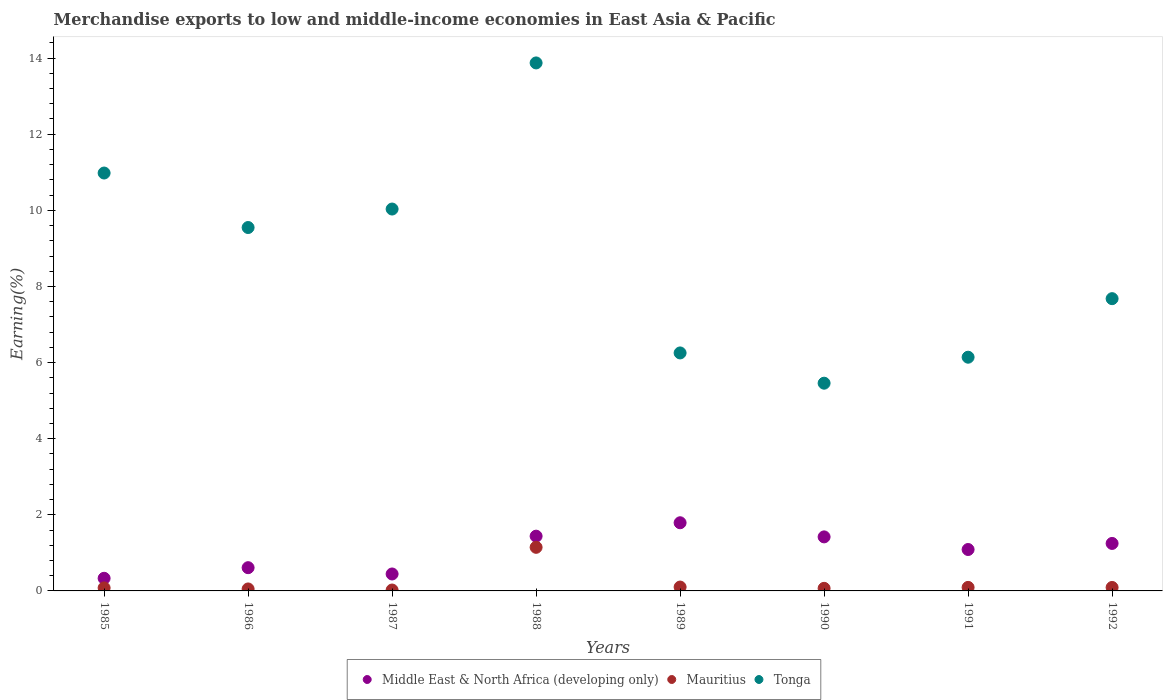How many different coloured dotlines are there?
Provide a short and direct response. 3. What is the percentage of amount earned from merchandise exports in Middle East & North Africa (developing only) in 1991?
Offer a terse response. 1.09. Across all years, what is the maximum percentage of amount earned from merchandise exports in Tonga?
Keep it short and to the point. 13.87. Across all years, what is the minimum percentage of amount earned from merchandise exports in Middle East & North Africa (developing only)?
Your response must be concise. 0.33. In which year was the percentage of amount earned from merchandise exports in Mauritius maximum?
Your answer should be very brief. 1988. What is the total percentage of amount earned from merchandise exports in Tonga in the graph?
Keep it short and to the point. 69.97. What is the difference between the percentage of amount earned from merchandise exports in Tonga in 1989 and that in 1992?
Your response must be concise. -1.43. What is the difference between the percentage of amount earned from merchandise exports in Mauritius in 1992 and the percentage of amount earned from merchandise exports in Middle East & North Africa (developing only) in 1986?
Your answer should be very brief. -0.52. What is the average percentage of amount earned from merchandise exports in Tonga per year?
Offer a terse response. 8.75. In the year 1989, what is the difference between the percentage of amount earned from merchandise exports in Mauritius and percentage of amount earned from merchandise exports in Middle East & North Africa (developing only)?
Offer a very short reply. -1.69. In how many years, is the percentage of amount earned from merchandise exports in Mauritius greater than 11.6 %?
Provide a succinct answer. 0. What is the ratio of the percentage of amount earned from merchandise exports in Tonga in 1986 to that in 1991?
Offer a very short reply. 1.55. Is the percentage of amount earned from merchandise exports in Middle East & North Africa (developing only) in 1986 less than that in 1990?
Provide a succinct answer. Yes. What is the difference between the highest and the second highest percentage of amount earned from merchandise exports in Middle East & North Africa (developing only)?
Your answer should be very brief. 0.35. What is the difference between the highest and the lowest percentage of amount earned from merchandise exports in Tonga?
Ensure brevity in your answer.  8.42. In how many years, is the percentage of amount earned from merchandise exports in Tonga greater than the average percentage of amount earned from merchandise exports in Tonga taken over all years?
Your answer should be compact. 4. Is the percentage of amount earned from merchandise exports in Tonga strictly greater than the percentage of amount earned from merchandise exports in Middle East & North Africa (developing only) over the years?
Offer a very short reply. Yes. Is the percentage of amount earned from merchandise exports in Mauritius strictly less than the percentage of amount earned from merchandise exports in Tonga over the years?
Your answer should be compact. Yes. What is the difference between two consecutive major ticks on the Y-axis?
Provide a succinct answer. 2. Are the values on the major ticks of Y-axis written in scientific E-notation?
Offer a very short reply. No. Does the graph contain any zero values?
Your answer should be very brief. No. Does the graph contain grids?
Provide a short and direct response. No. What is the title of the graph?
Offer a terse response. Merchandise exports to low and middle-income economies in East Asia & Pacific. Does "Sierra Leone" appear as one of the legend labels in the graph?
Provide a short and direct response. No. What is the label or title of the Y-axis?
Ensure brevity in your answer.  Earning(%). What is the Earning(%) in Middle East & North Africa (developing only) in 1985?
Ensure brevity in your answer.  0.33. What is the Earning(%) in Mauritius in 1985?
Make the answer very short. 0.08. What is the Earning(%) of Tonga in 1985?
Keep it short and to the point. 10.98. What is the Earning(%) of Middle East & North Africa (developing only) in 1986?
Your answer should be very brief. 0.61. What is the Earning(%) of Mauritius in 1986?
Provide a succinct answer. 0.05. What is the Earning(%) of Tonga in 1986?
Your response must be concise. 9.55. What is the Earning(%) of Middle East & North Africa (developing only) in 1987?
Make the answer very short. 0.45. What is the Earning(%) in Mauritius in 1987?
Offer a terse response. 0.02. What is the Earning(%) of Tonga in 1987?
Provide a succinct answer. 10.03. What is the Earning(%) of Middle East & North Africa (developing only) in 1988?
Your response must be concise. 1.44. What is the Earning(%) in Mauritius in 1988?
Keep it short and to the point. 1.15. What is the Earning(%) of Tonga in 1988?
Offer a very short reply. 13.87. What is the Earning(%) in Middle East & North Africa (developing only) in 1989?
Your answer should be compact. 1.79. What is the Earning(%) in Mauritius in 1989?
Keep it short and to the point. 0.1. What is the Earning(%) in Tonga in 1989?
Ensure brevity in your answer.  6.25. What is the Earning(%) in Middle East & North Africa (developing only) in 1990?
Provide a succinct answer. 1.42. What is the Earning(%) of Mauritius in 1990?
Provide a succinct answer. 0.07. What is the Earning(%) of Tonga in 1990?
Provide a succinct answer. 5.46. What is the Earning(%) of Middle East & North Africa (developing only) in 1991?
Offer a very short reply. 1.09. What is the Earning(%) in Mauritius in 1991?
Give a very brief answer. 0.09. What is the Earning(%) of Tonga in 1991?
Provide a short and direct response. 6.14. What is the Earning(%) in Middle East & North Africa (developing only) in 1992?
Your response must be concise. 1.25. What is the Earning(%) of Mauritius in 1992?
Ensure brevity in your answer.  0.09. What is the Earning(%) in Tonga in 1992?
Offer a very short reply. 7.68. Across all years, what is the maximum Earning(%) in Middle East & North Africa (developing only)?
Ensure brevity in your answer.  1.79. Across all years, what is the maximum Earning(%) in Mauritius?
Ensure brevity in your answer.  1.15. Across all years, what is the maximum Earning(%) of Tonga?
Your response must be concise. 13.87. Across all years, what is the minimum Earning(%) of Middle East & North Africa (developing only)?
Your answer should be compact. 0.33. Across all years, what is the minimum Earning(%) in Mauritius?
Offer a terse response. 0.02. Across all years, what is the minimum Earning(%) of Tonga?
Give a very brief answer. 5.46. What is the total Earning(%) of Middle East & North Africa (developing only) in the graph?
Your response must be concise. 8.37. What is the total Earning(%) in Mauritius in the graph?
Your response must be concise. 1.65. What is the total Earning(%) in Tonga in the graph?
Provide a short and direct response. 69.97. What is the difference between the Earning(%) in Middle East & North Africa (developing only) in 1985 and that in 1986?
Ensure brevity in your answer.  -0.28. What is the difference between the Earning(%) of Mauritius in 1985 and that in 1986?
Your answer should be very brief. 0.03. What is the difference between the Earning(%) in Tonga in 1985 and that in 1986?
Your answer should be compact. 1.43. What is the difference between the Earning(%) in Middle East & North Africa (developing only) in 1985 and that in 1987?
Offer a terse response. -0.11. What is the difference between the Earning(%) of Mauritius in 1985 and that in 1987?
Your answer should be compact. 0.06. What is the difference between the Earning(%) of Tonga in 1985 and that in 1987?
Keep it short and to the point. 0.95. What is the difference between the Earning(%) in Middle East & North Africa (developing only) in 1985 and that in 1988?
Your answer should be compact. -1.11. What is the difference between the Earning(%) in Mauritius in 1985 and that in 1988?
Make the answer very short. -1.07. What is the difference between the Earning(%) in Tonga in 1985 and that in 1988?
Keep it short and to the point. -2.89. What is the difference between the Earning(%) of Middle East & North Africa (developing only) in 1985 and that in 1989?
Your answer should be very brief. -1.46. What is the difference between the Earning(%) in Mauritius in 1985 and that in 1989?
Offer a terse response. -0.02. What is the difference between the Earning(%) of Tonga in 1985 and that in 1989?
Give a very brief answer. 4.73. What is the difference between the Earning(%) in Middle East & North Africa (developing only) in 1985 and that in 1990?
Ensure brevity in your answer.  -1.09. What is the difference between the Earning(%) in Mauritius in 1985 and that in 1990?
Ensure brevity in your answer.  0.01. What is the difference between the Earning(%) in Tonga in 1985 and that in 1990?
Keep it short and to the point. 5.52. What is the difference between the Earning(%) in Middle East & North Africa (developing only) in 1985 and that in 1991?
Give a very brief answer. -0.76. What is the difference between the Earning(%) of Mauritius in 1985 and that in 1991?
Offer a very short reply. -0.01. What is the difference between the Earning(%) in Tonga in 1985 and that in 1991?
Ensure brevity in your answer.  4.84. What is the difference between the Earning(%) of Middle East & North Africa (developing only) in 1985 and that in 1992?
Make the answer very short. -0.92. What is the difference between the Earning(%) of Mauritius in 1985 and that in 1992?
Give a very brief answer. -0.01. What is the difference between the Earning(%) of Tonga in 1985 and that in 1992?
Ensure brevity in your answer.  3.3. What is the difference between the Earning(%) in Middle East & North Africa (developing only) in 1986 and that in 1987?
Give a very brief answer. 0.17. What is the difference between the Earning(%) of Mauritius in 1986 and that in 1987?
Give a very brief answer. 0.03. What is the difference between the Earning(%) in Tonga in 1986 and that in 1987?
Your response must be concise. -0.49. What is the difference between the Earning(%) of Middle East & North Africa (developing only) in 1986 and that in 1988?
Provide a succinct answer. -0.83. What is the difference between the Earning(%) in Mauritius in 1986 and that in 1988?
Provide a short and direct response. -1.09. What is the difference between the Earning(%) in Tonga in 1986 and that in 1988?
Provide a short and direct response. -4.32. What is the difference between the Earning(%) in Middle East & North Africa (developing only) in 1986 and that in 1989?
Provide a succinct answer. -1.18. What is the difference between the Earning(%) of Mauritius in 1986 and that in 1989?
Your response must be concise. -0.05. What is the difference between the Earning(%) of Tonga in 1986 and that in 1989?
Make the answer very short. 3.3. What is the difference between the Earning(%) of Middle East & North Africa (developing only) in 1986 and that in 1990?
Your response must be concise. -0.81. What is the difference between the Earning(%) of Mauritius in 1986 and that in 1990?
Provide a short and direct response. -0.02. What is the difference between the Earning(%) of Tonga in 1986 and that in 1990?
Keep it short and to the point. 4.09. What is the difference between the Earning(%) of Middle East & North Africa (developing only) in 1986 and that in 1991?
Your answer should be compact. -0.48. What is the difference between the Earning(%) in Mauritius in 1986 and that in 1991?
Ensure brevity in your answer.  -0.04. What is the difference between the Earning(%) of Tonga in 1986 and that in 1991?
Keep it short and to the point. 3.41. What is the difference between the Earning(%) in Middle East & North Africa (developing only) in 1986 and that in 1992?
Your answer should be very brief. -0.64. What is the difference between the Earning(%) of Mauritius in 1986 and that in 1992?
Your response must be concise. -0.04. What is the difference between the Earning(%) of Tonga in 1986 and that in 1992?
Provide a succinct answer. 1.87. What is the difference between the Earning(%) in Middle East & North Africa (developing only) in 1987 and that in 1988?
Your response must be concise. -0.99. What is the difference between the Earning(%) in Mauritius in 1987 and that in 1988?
Provide a short and direct response. -1.12. What is the difference between the Earning(%) in Tonga in 1987 and that in 1988?
Keep it short and to the point. -3.84. What is the difference between the Earning(%) in Middle East & North Africa (developing only) in 1987 and that in 1989?
Your answer should be very brief. -1.35. What is the difference between the Earning(%) in Mauritius in 1987 and that in 1989?
Provide a short and direct response. -0.08. What is the difference between the Earning(%) of Tonga in 1987 and that in 1989?
Offer a very short reply. 3.78. What is the difference between the Earning(%) in Middle East & North Africa (developing only) in 1987 and that in 1990?
Your answer should be compact. -0.97. What is the difference between the Earning(%) in Mauritius in 1987 and that in 1990?
Provide a short and direct response. -0.04. What is the difference between the Earning(%) in Tonga in 1987 and that in 1990?
Offer a very short reply. 4.58. What is the difference between the Earning(%) of Middle East & North Africa (developing only) in 1987 and that in 1991?
Offer a terse response. -0.64. What is the difference between the Earning(%) of Mauritius in 1987 and that in 1991?
Keep it short and to the point. -0.07. What is the difference between the Earning(%) in Tonga in 1987 and that in 1991?
Provide a succinct answer. 3.89. What is the difference between the Earning(%) in Middle East & North Africa (developing only) in 1987 and that in 1992?
Provide a short and direct response. -0.8. What is the difference between the Earning(%) in Mauritius in 1987 and that in 1992?
Provide a succinct answer. -0.07. What is the difference between the Earning(%) of Tonga in 1987 and that in 1992?
Provide a short and direct response. 2.35. What is the difference between the Earning(%) of Middle East & North Africa (developing only) in 1988 and that in 1989?
Make the answer very short. -0.35. What is the difference between the Earning(%) in Mauritius in 1988 and that in 1989?
Provide a short and direct response. 1.04. What is the difference between the Earning(%) in Tonga in 1988 and that in 1989?
Your response must be concise. 7.62. What is the difference between the Earning(%) of Middle East & North Africa (developing only) in 1988 and that in 1990?
Your answer should be very brief. 0.02. What is the difference between the Earning(%) in Mauritius in 1988 and that in 1990?
Keep it short and to the point. 1.08. What is the difference between the Earning(%) in Tonga in 1988 and that in 1990?
Your answer should be compact. 8.42. What is the difference between the Earning(%) of Middle East & North Africa (developing only) in 1988 and that in 1991?
Give a very brief answer. 0.35. What is the difference between the Earning(%) in Mauritius in 1988 and that in 1991?
Keep it short and to the point. 1.05. What is the difference between the Earning(%) in Tonga in 1988 and that in 1991?
Offer a terse response. 7.73. What is the difference between the Earning(%) of Middle East & North Africa (developing only) in 1988 and that in 1992?
Ensure brevity in your answer.  0.19. What is the difference between the Earning(%) of Mauritius in 1988 and that in 1992?
Provide a succinct answer. 1.05. What is the difference between the Earning(%) of Tonga in 1988 and that in 1992?
Ensure brevity in your answer.  6.19. What is the difference between the Earning(%) in Middle East & North Africa (developing only) in 1989 and that in 1990?
Provide a short and direct response. 0.37. What is the difference between the Earning(%) of Mauritius in 1989 and that in 1990?
Keep it short and to the point. 0.03. What is the difference between the Earning(%) of Tonga in 1989 and that in 1990?
Offer a terse response. 0.8. What is the difference between the Earning(%) of Middle East & North Africa (developing only) in 1989 and that in 1991?
Provide a succinct answer. 0.7. What is the difference between the Earning(%) in Mauritius in 1989 and that in 1991?
Provide a succinct answer. 0.01. What is the difference between the Earning(%) in Tonga in 1989 and that in 1991?
Offer a very short reply. 0.11. What is the difference between the Earning(%) in Middle East & North Africa (developing only) in 1989 and that in 1992?
Keep it short and to the point. 0.54. What is the difference between the Earning(%) of Mauritius in 1989 and that in 1992?
Offer a terse response. 0.01. What is the difference between the Earning(%) of Tonga in 1989 and that in 1992?
Offer a very short reply. -1.43. What is the difference between the Earning(%) of Middle East & North Africa (developing only) in 1990 and that in 1991?
Offer a terse response. 0.33. What is the difference between the Earning(%) of Mauritius in 1990 and that in 1991?
Your answer should be compact. -0.02. What is the difference between the Earning(%) of Tonga in 1990 and that in 1991?
Offer a very short reply. -0.68. What is the difference between the Earning(%) in Middle East & North Africa (developing only) in 1990 and that in 1992?
Give a very brief answer. 0.17. What is the difference between the Earning(%) in Mauritius in 1990 and that in 1992?
Keep it short and to the point. -0.02. What is the difference between the Earning(%) in Tonga in 1990 and that in 1992?
Make the answer very short. -2.22. What is the difference between the Earning(%) of Middle East & North Africa (developing only) in 1991 and that in 1992?
Give a very brief answer. -0.16. What is the difference between the Earning(%) of Mauritius in 1991 and that in 1992?
Ensure brevity in your answer.  0. What is the difference between the Earning(%) in Tonga in 1991 and that in 1992?
Provide a succinct answer. -1.54. What is the difference between the Earning(%) of Middle East & North Africa (developing only) in 1985 and the Earning(%) of Mauritius in 1986?
Give a very brief answer. 0.28. What is the difference between the Earning(%) of Middle East & North Africa (developing only) in 1985 and the Earning(%) of Tonga in 1986?
Your answer should be very brief. -9.22. What is the difference between the Earning(%) of Mauritius in 1985 and the Earning(%) of Tonga in 1986?
Offer a terse response. -9.47. What is the difference between the Earning(%) in Middle East & North Africa (developing only) in 1985 and the Earning(%) in Mauritius in 1987?
Provide a succinct answer. 0.31. What is the difference between the Earning(%) of Middle East & North Africa (developing only) in 1985 and the Earning(%) of Tonga in 1987?
Keep it short and to the point. -9.7. What is the difference between the Earning(%) of Mauritius in 1985 and the Earning(%) of Tonga in 1987?
Provide a short and direct response. -9.95. What is the difference between the Earning(%) of Middle East & North Africa (developing only) in 1985 and the Earning(%) of Mauritius in 1988?
Give a very brief answer. -0.81. What is the difference between the Earning(%) in Middle East & North Africa (developing only) in 1985 and the Earning(%) in Tonga in 1988?
Ensure brevity in your answer.  -13.54. What is the difference between the Earning(%) in Mauritius in 1985 and the Earning(%) in Tonga in 1988?
Your answer should be compact. -13.79. What is the difference between the Earning(%) of Middle East & North Africa (developing only) in 1985 and the Earning(%) of Mauritius in 1989?
Ensure brevity in your answer.  0.23. What is the difference between the Earning(%) of Middle East & North Africa (developing only) in 1985 and the Earning(%) of Tonga in 1989?
Provide a short and direct response. -5.92. What is the difference between the Earning(%) of Mauritius in 1985 and the Earning(%) of Tonga in 1989?
Provide a succinct answer. -6.17. What is the difference between the Earning(%) in Middle East & North Africa (developing only) in 1985 and the Earning(%) in Mauritius in 1990?
Make the answer very short. 0.26. What is the difference between the Earning(%) of Middle East & North Africa (developing only) in 1985 and the Earning(%) of Tonga in 1990?
Give a very brief answer. -5.13. What is the difference between the Earning(%) in Mauritius in 1985 and the Earning(%) in Tonga in 1990?
Your answer should be very brief. -5.38. What is the difference between the Earning(%) of Middle East & North Africa (developing only) in 1985 and the Earning(%) of Mauritius in 1991?
Ensure brevity in your answer.  0.24. What is the difference between the Earning(%) in Middle East & North Africa (developing only) in 1985 and the Earning(%) in Tonga in 1991?
Make the answer very short. -5.81. What is the difference between the Earning(%) in Mauritius in 1985 and the Earning(%) in Tonga in 1991?
Your answer should be very brief. -6.06. What is the difference between the Earning(%) in Middle East & North Africa (developing only) in 1985 and the Earning(%) in Mauritius in 1992?
Your response must be concise. 0.24. What is the difference between the Earning(%) in Middle East & North Africa (developing only) in 1985 and the Earning(%) in Tonga in 1992?
Offer a very short reply. -7.35. What is the difference between the Earning(%) of Mauritius in 1985 and the Earning(%) of Tonga in 1992?
Your response must be concise. -7.6. What is the difference between the Earning(%) in Middle East & North Africa (developing only) in 1986 and the Earning(%) in Mauritius in 1987?
Provide a short and direct response. 0.59. What is the difference between the Earning(%) in Middle East & North Africa (developing only) in 1986 and the Earning(%) in Tonga in 1987?
Provide a short and direct response. -9.42. What is the difference between the Earning(%) of Mauritius in 1986 and the Earning(%) of Tonga in 1987?
Your response must be concise. -9.98. What is the difference between the Earning(%) of Middle East & North Africa (developing only) in 1986 and the Earning(%) of Mauritius in 1988?
Offer a terse response. -0.54. What is the difference between the Earning(%) of Middle East & North Africa (developing only) in 1986 and the Earning(%) of Tonga in 1988?
Ensure brevity in your answer.  -13.26. What is the difference between the Earning(%) in Mauritius in 1986 and the Earning(%) in Tonga in 1988?
Offer a very short reply. -13.82. What is the difference between the Earning(%) in Middle East & North Africa (developing only) in 1986 and the Earning(%) in Mauritius in 1989?
Offer a very short reply. 0.51. What is the difference between the Earning(%) in Middle East & North Africa (developing only) in 1986 and the Earning(%) in Tonga in 1989?
Offer a terse response. -5.64. What is the difference between the Earning(%) of Mauritius in 1986 and the Earning(%) of Tonga in 1989?
Offer a very short reply. -6.2. What is the difference between the Earning(%) of Middle East & North Africa (developing only) in 1986 and the Earning(%) of Mauritius in 1990?
Your response must be concise. 0.54. What is the difference between the Earning(%) of Middle East & North Africa (developing only) in 1986 and the Earning(%) of Tonga in 1990?
Your answer should be compact. -4.85. What is the difference between the Earning(%) of Mauritius in 1986 and the Earning(%) of Tonga in 1990?
Keep it short and to the point. -5.41. What is the difference between the Earning(%) of Middle East & North Africa (developing only) in 1986 and the Earning(%) of Mauritius in 1991?
Ensure brevity in your answer.  0.52. What is the difference between the Earning(%) of Middle East & North Africa (developing only) in 1986 and the Earning(%) of Tonga in 1991?
Your answer should be very brief. -5.53. What is the difference between the Earning(%) of Mauritius in 1986 and the Earning(%) of Tonga in 1991?
Offer a terse response. -6.09. What is the difference between the Earning(%) of Middle East & North Africa (developing only) in 1986 and the Earning(%) of Mauritius in 1992?
Your response must be concise. 0.52. What is the difference between the Earning(%) of Middle East & North Africa (developing only) in 1986 and the Earning(%) of Tonga in 1992?
Your answer should be compact. -7.07. What is the difference between the Earning(%) in Mauritius in 1986 and the Earning(%) in Tonga in 1992?
Keep it short and to the point. -7.63. What is the difference between the Earning(%) in Middle East & North Africa (developing only) in 1987 and the Earning(%) in Mauritius in 1988?
Offer a terse response. -0.7. What is the difference between the Earning(%) of Middle East & North Africa (developing only) in 1987 and the Earning(%) of Tonga in 1988?
Provide a short and direct response. -13.43. What is the difference between the Earning(%) of Mauritius in 1987 and the Earning(%) of Tonga in 1988?
Your answer should be compact. -13.85. What is the difference between the Earning(%) in Middle East & North Africa (developing only) in 1987 and the Earning(%) in Mauritius in 1989?
Offer a very short reply. 0.34. What is the difference between the Earning(%) in Middle East & North Africa (developing only) in 1987 and the Earning(%) in Tonga in 1989?
Provide a short and direct response. -5.81. What is the difference between the Earning(%) in Mauritius in 1987 and the Earning(%) in Tonga in 1989?
Your answer should be very brief. -6.23. What is the difference between the Earning(%) of Middle East & North Africa (developing only) in 1987 and the Earning(%) of Mauritius in 1990?
Provide a short and direct response. 0.38. What is the difference between the Earning(%) in Middle East & North Africa (developing only) in 1987 and the Earning(%) in Tonga in 1990?
Ensure brevity in your answer.  -5.01. What is the difference between the Earning(%) of Mauritius in 1987 and the Earning(%) of Tonga in 1990?
Offer a very short reply. -5.43. What is the difference between the Earning(%) in Middle East & North Africa (developing only) in 1987 and the Earning(%) in Mauritius in 1991?
Ensure brevity in your answer.  0.35. What is the difference between the Earning(%) of Middle East & North Africa (developing only) in 1987 and the Earning(%) of Tonga in 1991?
Offer a very short reply. -5.7. What is the difference between the Earning(%) of Mauritius in 1987 and the Earning(%) of Tonga in 1991?
Your answer should be compact. -6.12. What is the difference between the Earning(%) in Middle East & North Africa (developing only) in 1987 and the Earning(%) in Mauritius in 1992?
Give a very brief answer. 0.35. What is the difference between the Earning(%) of Middle East & North Africa (developing only) in 1987 and the Earning(%) of Tonga in 1992?
Provide a succinct answer. -7.23. What is the difference between the Earning(%) of Mauritius in 1987 and the Earning(%) of Tonga in 1992?
Keep it short and to the point. -7.66. What is the difference between the Earning(%) of Middle East & North Africa (developing only) in 1988 and the Earning(%) of Mauritius in 1989?
Ensure brevity in your answer.  1.34. What is the difference between the Earning(%) of Middle East & North Africa (developing only) in 1988 and the Earning(%) of Tonga in 1989?
Provide a short and direct response. -4.81. What is the difference between the Earning(%) of Mauritius in 1988 and the Earning(%) of Tonga in 1989?
Offer a very short reply. -5.11. What is the difference between the Earning(%) of Middle East & North Africa (developing only) in 1988 and the Earning(%) of Mauritius in 1990?
Give a very brief answer. 1.37. What is the difference between the Earning(%) in Middle East & North Africa (developing only) in 1988 and the Earning(%) in Tonga in 1990?
Make the answer very short. -4.02. What is the difference between the Earning(%) of Mauritius in 1988 and the Earning(%) of Tonga in 1990?
Provide a short and direct response. -4.31. What is the difference between the Earning(%) in Middle East & North Africa (developing only) in 1988 and the Earning(%) in Mauritius in 1991?
Your response must be concise. 1.35. What is the difference between the Earning(%) in Middle East & North Africa (developing only) in 1988 and the Earning(%) in Tonga in 1991?
Give a very brief answer. -4.7. What is the difference between the Earning(%) in Mauritius in 1988 and the Earning(%) in Tonga in 1991?
Your answer should be very brief. -5. What is the difference between the Earning(%) of Middle East & North Africa (developing only) in 1988 and the Earning(%) of Mauritius in 1992?
Make the answer very short. 1.35. What is the difference between the Earning(%) of Middle East & North Africa (developing only) in 1988 and the Earning(%) of Tonga in 1992?
Give a very brief answer. -6.24. What is the difference between the Earning(%) of Mauritius in 1988 and the Earning(%) of Tonga in 1992?
Offer a very short reply. -6.53. What is the difference between the Earning(%) of Middle East & North Africa (developing only) in 1989 and the Earning(%) of Mauritius in 1990?
Keep it short and to the point. 1.72. What is the difference between the Earning(%) in Middle East & North Africa (developing only) in 1989 and the Earning(%) in Tonga in 1990?
Your response must be concise. -3.67. What is the difference between the Earning(%) in Mauritius in 1989 and the Earning(%) in Tonga in 1990?
Provide a short and direct response. -5.36. What is the difference between the Earning(%) in Middle East & North Africa (developing only) in 1989 and the Earning(%) in Mauritius in 1991?
Provide a succinct answer. 1.7. What is the difference between the Earning(%) of Middle East & North Africa (developing only) in 1989 and the Earning(%) of Tonga in 1991?
Offer a very short reply. -4.35. What is the difference between the Earning(%) of Mauritius in 1989 and the Earning(%) of Tonga in 1991?
Provide a short and direct response. -6.04. What is the difference between the Earning(%) of Middle East & North Africa (developing only) in 1989 and the Earning(%) of Mauritius in 1992?
Your answer should be compact. 1.7. What is the difference between the Earning(%) of Middle East & North Africa (developing only) in 1989 and the Earning(%) of Tonga in 1992?
Make the answer very short. -5.89. What is the difference between the Earning(%) of Mauritius in 1989 and the Earning(%) of Tonga in 1992?
Provide a succinct answer. -7.58. What is the difference between the Earning(%) in Middle East & North Africa (developing only) in 1990 and the Earning(%) in Mauritius in 1991?
Make the answer very short. 1.33. What is the difference between the Earning(%) of Middle East & North Africa (developing only) in 1990 and the Earning(%) of Tonga in 1991?
Your answer should be very brief. -4.72. What is the difference between the Earning(%) in Mauritius in 1990 and the Earning(%) in Tonga in 1991?
Your response must be concise. -6.07. What is the difference between the Earning(%) of Middle East & North Africa (developing only) in 1990 and the Earning(%) of Mauritius in 1992?
Offer a very short reply. 1.33. What is the difference between the Earning(%) of Middle East & North Africa (developing only) in 1990 and the Earning(%) of Tonga in 1992?
Your answer should be very brief. -6.26. What is the difference between the Earning(%) of Mauritius in 1990 and the Earning(%) of Tonga in 1992?
Give a very brief answer. -7.61. What is the difference between the Earning(%) in Middle East & North Africa (developing only) in 1991 and the Earning(%) in Mauritius in 1992?
Keep it short and to the point. 1. What is the difference between the Earning(%) of Middle East & North Africa (developing only) in 1991 and the Earning(%) of Tonga in 1992?
Ensure brevity in your answer.  -6.59. What is the difference between the Earning(%) in Mauritius in 1991 and the Earning(%) in Tonga in 1992?
Ensure brevity in your answer.  -7.59. What is the average Earning(%) in Middle East & North Africa (developing only) per year?
Provide a succinct answer. 1.05. What is the average Earning(%) of Mauritius per year?
Ensure brevity in your answer.  0.21. What is the average Earning(%) in Tonga per year?
Provide a short and direct response. 8.75. In the year 1985, what is the difference between the Earning(%) in Middle East & North Africa (developing only) and Earning(%) in Mauritius?
Offer a terse response. 0.25. In the year 1985, what is the difference between the Earning(%) of Middle East & North Africa (developing only) and Earning(%) of Tonga?
Provide a short and direct response. -10.65. In the year 1985, what is the difference between the Earning(%) of Mauritius and Earning(%) of Tonga?
Make the answer very short. -10.9. In the year 1986, what is the difference between the Earning(%) in Middle East & North Africa (developing only) and Earning(%) in Mauritius?
Offer a terse response. 0.56. In the year 1986, what is the difference between the Earning(%) of Middle East & North Africa (developing only) and Earning(%) of Tonga?
Ensure brevity in your answer.  -8.94. In the year 1986, what is the difference between the Earning(%) of Mauritius and Earning(%) of Tonga?
Offer a terse response. -9.5. In the year 1987, what is the difference between the Earning(%) in Middle East & North Africa (developing only) and Earning(%) in Mauritius?
Provide a short and direct response. 0.42. In the year 1987, what is the difference between the Earning(%) of Middle East & North Africa (developing only) and Earning(%) of Tonga?
Your answer should be compact. -9.59. In the year 1987, what is the difference between the Earning(%) of Mauritius and Earning(%) of Tonga?
Offer a terse response. -10.01. In the year 1988, what is the difference between the Earning(%) in Middle East & North Africa (developing only) and Earning(%) in Mauritius?
Give a very brief answer. 0.29. In the year 1988, what is the difference between the Earning(%) of Middle East & North Africa (developing only) and Earning(%) of Tonga?
Provide a succinct answer. -12.43. In the year 1988, what is the difference between the Earning(%) in Mauritius and Earning(%) in Tonga?
Offer a terse response. -12.73. In the year 1989, what is the difference between the Earning(%) of Middle East & North Africa (developing only) and Earning(%) of Mauritius?
Make the answer very short. 1.69. In the year 1989, what is the difference between the Earning(%) of Middle East & North Africa (developing only) and Earning(%) of Tonga?
Provide a succinct answer. -4.46. In the year 1989, what is the difference between the Earning(%) in Mauritius and Earning(%) in Tonga?
Provide a succinct answer. -6.15. In the year 1990, what is the difference between the Earning(%) of Middle East & North Africa (developing only) and Earning(%) of Mauritius?
Make the answer very short. 1.35. In the year 1990, what is the difference between the Earning(%) in Middle East & North Africa (developing only) and Earning(%) in Tonga?
Keep it short and to the point. -4.04. In the year 1990, what is the difference between the Earning(%) in Mauritius and Earning(%) in Tonga?
Offer a very short reply. -5.39. In the year 1991, what is the difference between the Earning(%) of Middle East & North Africa (developing only) and Earning(%) of Tonga?
Offer a terse response. -5.05. In the year 1991, what is the difference between the Earning(%) of Mauritius and Earning(%) of Tonga?
Give a very brief answer. -6.05. In the year 1992, what is the difference between the Earning(%) in Middle East & North Africa (developing only) and Earning(%) in Mauritius?
Your response must be concise. 1.16. In the year 1992, what is the difference between the Earning(%) in Middle East & North Africa (developing only) and Earning(%) in Tonga?
Offer a terse response. -6.43. In the year 1992, what is the difference between the Earning(%) in Mauritius and Earning(%) in Tonga?
Your answer should be compact. -7.59. What is the ratio of the Earning(%) of Middle East & North Africa (developing only) in 1985 to that in 1986?
Your response must be concise. 0.54. What is the ratio of the Earning(%) in Mauritius in 1985 to that in 1986?
Make the answer very short. 1.53. What is the ratio of the Earning(%) in Tonga in 1985 to that in 1986?
Offer a very short reply. 1.15. What is the ratio of the Earning(%) of Middle East & North Africa (developing only) in 1985 to that in 1987?
Your response must be concise. 0.75. What is the ratio of the Earning(%) in Mauritius in 1985 to that in 1987?
Your answer should be very brief. 3.35. What is the ratio of the Earning(%) of Tonga in 1985 to that in 1987?
Your answer should be compact. 1.09. What is the ratio of the Earning(%) of Middle East & North Africa (developing only) in 1985 to that in 1988?
Your response must be concise. 0.23. What is the ratio of the Earning(%) in Mauritius in 1985 to that in 1988?
Offer a very short reply. 0.07. What is the ratio of the Earning(%) of Tonga in 1985 to that in 1988?
Keep it short and to the point. 0.79. What is the ratio of the Earning(%) of Middle East & North Africa (developing only) in 1985 to that in 1989?
Your response must be concise. 0.19. What is the ratio of the Earning(%) in Mauritius in 1985 to that in 1989?
Offer a terse response. 0.78. What is the ratio of the Earning(%) in Tonga in 1985 to that in 1989?
Make the answer very short. 1.76. What is the ratio of the Earning(%) of Middle East & North Africa (developing only) in 1985 to that in 1990?
Offer a terse response. 0.23. What is the ratio of the Earning(%) of Mauritius in 1985 to that in 1990?
Provide a short and direct response. 1.17. What is the ratio of the Earning(%) in Tonga in 1985 to that in 1990?
Make the answer very short. 2.01. What is the ratio of the Earning(%) of Middle East & North Africa (developing only) in 1985 to that in 1991?
Ensure brevity in your answer.  0.3. What is the ratio of the Earning(%) in Mauritius in 1985 to that in 1991?
Give a very brief answer. 0.86. What is the ratio of the Earning(%) in Tonga in 1985 to that in 1991?
Your answer should be very brief. 1.79. What is the ratio of the Earning(%) of Middle East & North Africa (developing only) in 1985 to that in 1992?
Provide a short and direct response. 0.27. What is the ratio of the Earning(%) in Mauritius in 1985 to that in 1992?
Provide a short and direct response. 0.87. What is the ratio of the Earning(%) in Tonga in 1985 to that in 1992?
Provide a short and direct response. 1.43. What is the ratio of the Earning(%) of Middle East & North Africa (developing only) in 1986 to that in 1987?
Keep it short and to the point. 1.37. What is the ratio of the Earning(%) of Mauritius in 1986 to that in 1987?
Your answer should be very brief. 2.19. What is the ratio of the Earning(%) of Tonga in 1986 to that in 1987?
Make the answer very short. 0.95. What is the ratio of the Earning(%) in Middle East & North Africa (developing only) in 1986 to that in 1988?
Provide a short and direct response. 0.42. What is the ratio of the Earning(%) in Mauritius in 1986 to that in 1988?
Give a very brief answer. 0.05. What is the ratio of the Earning(%) of Tonga in 1986 to that in 1988?
Your answer should be compact. 0.69. What is the ratio of the Earning(%) of Middle East & North Africa (developing only) in 1986 to that in 1989?
Offer a very short reply. 0.34. What is the ratio of the Earning(%) of Mauritius in 1986 to that in 1989?
Your response must be concise. 0.51. What is the ratio of the Earning(%) in Tonga in 1986 to that in 1989?
Provide a short and direct response. 1.53. What is the ratio of the Earning(%) in Middle East & North Africa (developing only) in 1986 to that in 1990?
Your response must be concise. 0.43. What is the ratio of the Earning(%) of Mauritius in 1986 to that in 1990?
Your answer should be very brief. 0.76. What is the ratio of the Earning(%) in Tonga in 1986 to that in 1990?
Give a very brief answer. 1.75. What is the ratio of the Earning(%) in Middle East & North Africa (developing only) in 1986 to that in 1991?
Ensure brevity in your answer.  0.56. What is the ratio of the Earning(%) in Mauritius in 1986 to that in 1991?
Make the answer very short. 0.56. What is the ratio of the Earning(%) of Tonga in 1986 to that in 1991?
Your answer should be compact. 1.55. What is the ratio of the Earning(%) in Middle East & North Africa (developing only) in 1986 to that in 1992?
Offer a terse response. 0.49. What is the ratio of the Earning(%) of Mauritius in 1986 to that in 1992?
Provide a short and direct response. 0.57. What is the ratio of the Earning(%) of Tonga in 1986 to that in 1992?
Your answer should be very brief. 1.24. What is the ratio of the Earning(%) of Middle East & North Africa (developing only) in 1987 to that in 1988?
Your answer should be compact. 0.31. What is the ratio of the Earning(%) of Mauritius in 1987 to that in 1988?
Offer a very short reply. 0.02. What is the ratio of the Earning(%) in Tonga in 1987 to that in 1988?
Offer a terse response. 0.72. What is the ratio of the Earning(%) of Middle East & North Africa (developing only) in 1987 to that in 1989?
Your answer should be compact. 0.25. What is the ratio of the Earning(%) in Mauritius in 1987 to that in 1989?
Your answer should be very brief. 0.23. What is the ratio of the Earning(%) in Tonga in 1987 to that in 1989?
Provide a succinct answer. 1.6. What is the ratio of the Earning(%) of Middle East & North Africa (developing only) in 1987 to that in 1990?
Offer a terse response. 0.31. What is the ratio of the Earning(%) of Mauritius in 1987 to that in 1990?
Provide a short and direct response. 0.35. What is the ratio of the Earning(%) of Tonga in 1987 to that in 1990?
Your answer should be compact. 1.84. What is the ratio of the Earning(%) in Middle East & North Africa (developing only) in 1987 to that in 1991?
Provide a short and direct response. 0.41. What is the ratio of the Earning(%) of Mauritius in 1987 to that in 1991?
Your response must be concise. 0.26. What is the ratio of the Earning(%) in Tonga in 1987 to that in 1991?
Keep it short and to the point. 1.63. What is the ratio of the Earning(%) in Middle East & North Africa (developing only) in 1987 to that in 1992?
Give a very brief answer. 0.36. What is the ratio of the Earning(%) in Mauritius in 1987 to that in 1992?
Your answer should be compact. 0.26. What is the ratio of the Earning(%) of Tonga in 1987 to that in 1992?
Your answer should be compact. 1.31. What is the ratio of the Earning(%) in Middle East & North Africa (developing only) in 1988 to that in 1989?
Ensure brevity in your answer.  0.8. What is the ratio of the Earning(%) of Mauritius in 1988 to that in 1989?
Provide a succinct answer. 11.26. What is the ratio of the Earning(%) in Tonga in 1988 to that in 1989?
Offer a terse response. 2.22. What is the ratio of the Earning(%) in Middle East & North Africa (developing only) in 1988 to that in 1990?
Your answer should be compact. 1.01. What is the ratio of the Earning(%) of Mauritius in 1988 to that in 1990?
Give a very brief answer. 16.89. What is the ratio of the Earning(%) in Tonga in 1988 to that in 1990?
Provide a short and direct response. 2.54. What is the ratio of the Earning(%) of Middle East & North Africa (developing only) in 1988 to that in 1991?
Give a very brief answer. 1.32. What is the ratio of the Earning(%) of Mauritius in 1988 to that in 1991?
Provide a short and direct response. 12.36. What is the ratio of the Earning(%) in Tonga in 1988 to that in 1991?
Keep it short and to the point. 2.26. What is the ratio of the Earning(%) in Middle East & North Africa (developing only) in 1988 to that in 1992?
Ensure brevity in your answer.  1.15. What is the ratio of the Earning(%) of Mauritius in 1988 to that in 1992?
Ensure brevity in your answer.  12.6. What is the ratio of the Earning(%) in Tonga in 1988 to that in 1992?
Provide a succinct answer. 1.81. What is the ratio of the Earning(%) of Middle East & North Africa (developing only) in 1989 to that in 1990?
Your response must be concise. 1.26. What is the ratio of the Earning(%) of Mauritius in 1989 to that in 1990?
Ensure brevity in your answer.  1.5. What is the ratio of the Earning(%) in Tonga in 1989 to that in 1990?
Offer a very short reply. 1.15. What is the ratio of the Earning(%) in Middle East & North Africa (developing only) in 1989 to that in 1991?
Your response must be concise. 1.65. What is the ratio of the Earning(%) in Mauritius in 1989 to that in 1991?
Provide a succinct answer. 1.1. What is the ratio of the Earning(%) in Tonga in 1989 to that in 1991?
Your response must be concise. 1.02. What is the ratio of the Earning(%) in Middle East & North Africa (developing only) in 1989 to that in 1992?
Offer a terse response. 1.44. What is the ratio of the Earning(%) of Mauritius in 1989 to that in 1992?
Give a very brief answer. 1.12. What is the ratio of the Earning(%) of Tonga in 1989 to that in 1992?
Offer a terse response. 0.81. What is the ratio of the Earning(%) of Middle East & North Africa (developing only) in 1990 to that in 1991?
Provide a succinct answer. 1.3. What is the ratio of the Earning(%) of Mauritius in 1990 to that in 1991?
Give a very brief answer. 0.73. What is the ratio of the Earning(%) of Tonga in 1990 to that in 1991?
Provide a succinct answer. 0.89. What is the ratio of the Earning(%) of Middle East & North Africa (developing only) in 1990 to that in 1992?
Offer a very short reply. 1.14. What is the ratio of the Earning(%) in Mauritius in 1990 to that in 1992?
Offer a terse response. 0.75. What is the ratio of the Earning(%) of Tonga in 1990 to that in 1992?
Offer a terse response. 0.71. What is the ratio of the Earning(%) of Middle East & North Africa (developing only) in 1991 to that in 1992?
Ensure brevity in your answer.  0.87. What is the ratio of the Earning(%) in Mauritius in 1991 to that in 1992?
Your answer should be very brief. 1.02. What is the ratio of the Earning(%) in Tonga in 1991 to that in 1992?
Make the answer very short. 0.8. What is the difference between the highest and the second highest Earning(%) of Middle East & North Africa (developing only)?
Provide a short and direct response. 0.35. What is the difference between the highest and the second highest Earning(%) of Mauritius?
Provide a succinct answer. 1.04. What is the difference between the highest and the second highest Earning(%) in Tonga?
Keep it short and to the point. 2.89. What is the difference between the highest and the lowest Earning(%) of Middle East & North Africa (developing only)?
Offer a very short reply. 1.46. What is the difference between the highest and the lowest Earning(%) of Mauritius?
Offer a terse response. 1.12. What is the difference between the highest and the lowest Earning(%) of Tonga?
Your answer should be very brief. 8.42. 